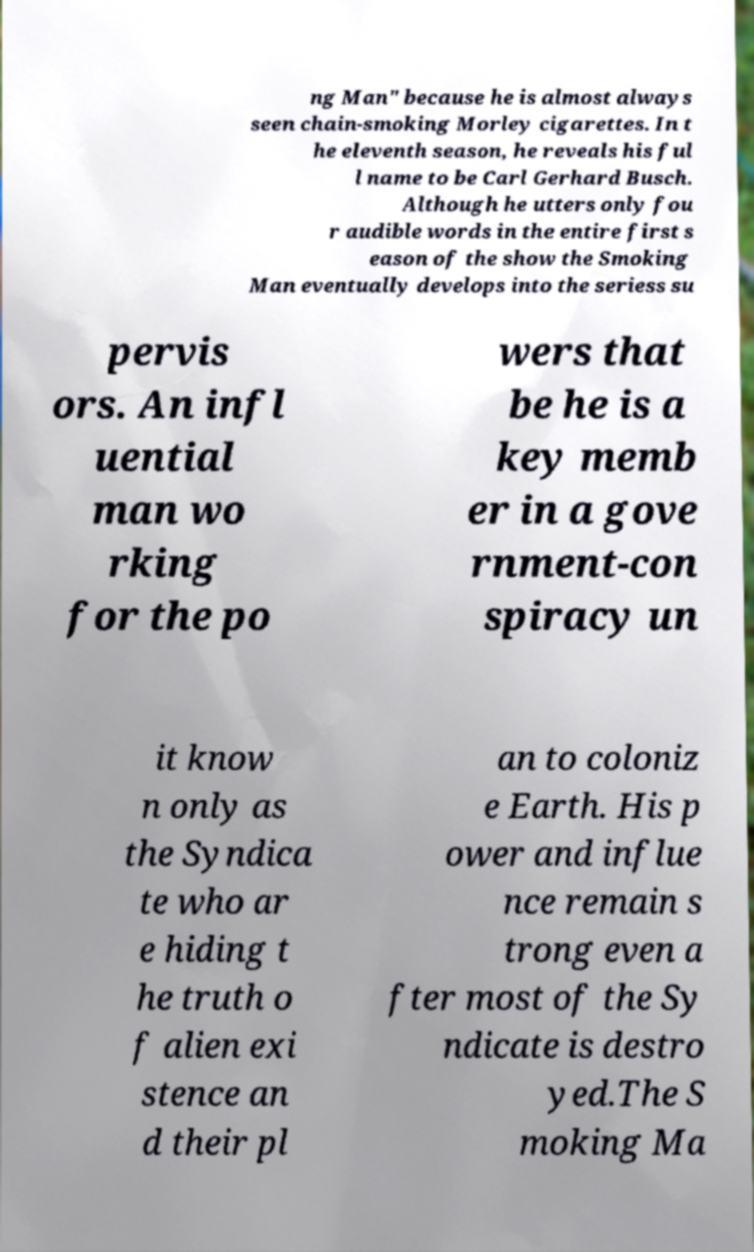Please read and relay the text visible in this image. What does it say? ng Man" because he is almost always seen chain-smoking Morley cigarettes. In t he eleventh season, he reveals his ful l name to be Carl Gerhard Busch. Although he utters only fou r audible words in the entire first s eason of the show the Smoking Man eventually develops into the seriess su pervis ors. An infl uential man wo rking for the po wers that be he is a key memb er in a gove rnment-con spiracy un it know n only as the Syndica te who ar e hiding t he truth o f alien exi stence an d their pl an to coloniz e Earth. His p ower and influe nce remain s trong even a fter most of the Sy ndicate is destro yed.The S moking Ma 